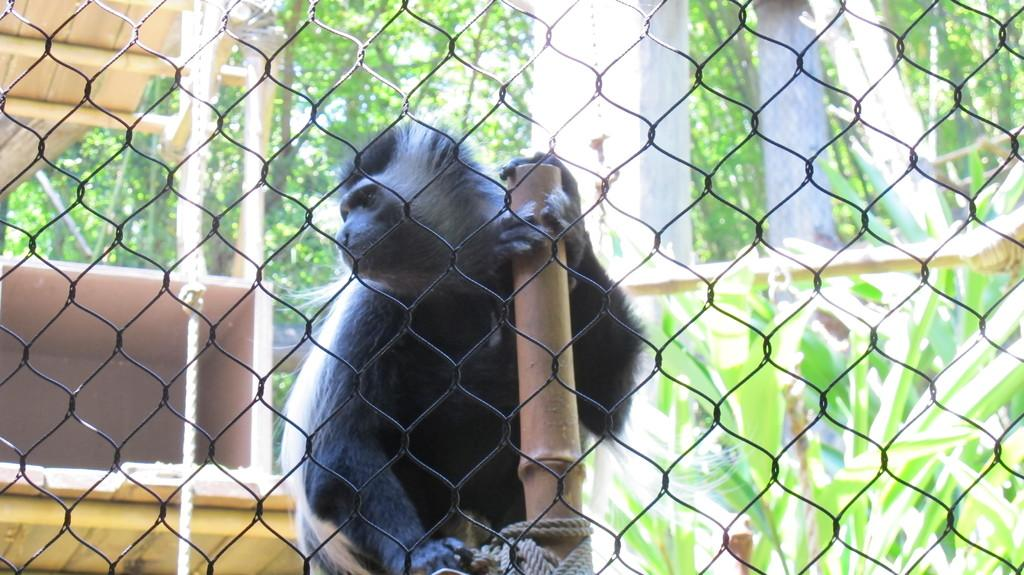What type of barrier can be seen in the image? There is a fence in the image. What animal is present in the image? There is a monkey in the image. Where is the monkey located in relation to the fence? The monkey is behind the fence. What other objects can be seen in the image? There is a wooden pole and a rope in the image. What type of vegetation is visible in the image? Trees are visible in the image. What type of engine is powering the monkey's apparatus in the image? There is no engine or apparatus present in the image; it features a monkey behind a fence with a wooden pole and a rope. What time of day is depicted in the image? The time of day is not specified in the image, so it cannot be determined from the image alone. 